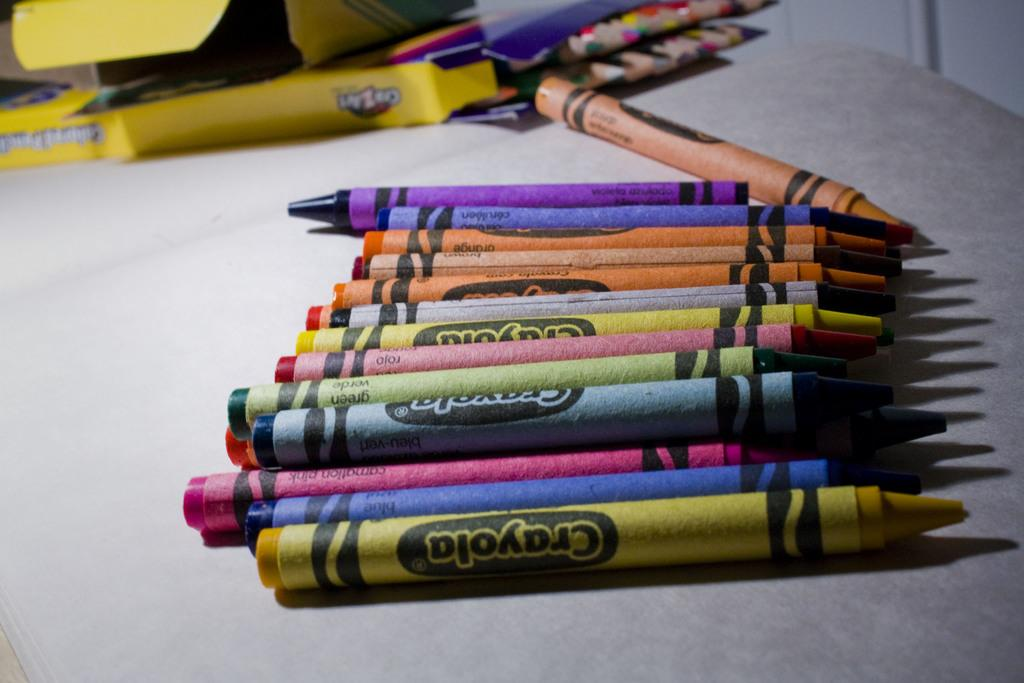What objects are present in the image? There are crayons and boxes in the image. Where are the crayons and boxes located? The crayons and boxes are on a table. Can you describe the setting of the image? The image may have been taken in a room, but this cannot be confirmed with certainty based on the transcript alone. How many lizards can be seen crawling on the boxes in the image? There are no lizards present in the image; it only features crayons and boxes on a table. What type of vegetable is being used as a toy in the image? There is no vegetable present in the image, and no toys are visible either. 